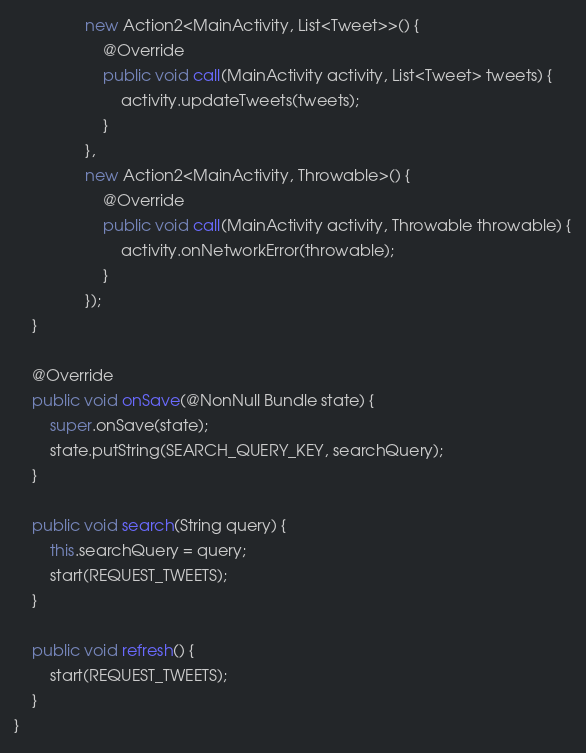<code> <loc_0><loc_0><loc_500><loc_500><_Java_>                new Action2<MainActivity, List<Tweet>>() {
                    @Override
                    public void call(MainActivity activity, List<Tweet> tweets) {
                        activity.updateTweets(tweets);
                    }
                },
                new Action2<MainActivity, Throwable>() {
                    @Override
                    public void call(MainActivity activity, Throwable throwable) {
                        activity.onNetworkError(throwable);
                    }
                });
    }

    @Override
    public void onSave(@NonNull Bundle state) {
        super.onSave(state);
        state.putString(SEARCH_QUERY_KEY, searchQuery);
    }

    public void search(String query) {
        this.searchQuery = query;
        start(REQUEST_TWEETS);
    }

    public void refresh() {
        start(REQUEST_TWEETS);
    }
}
</code> 